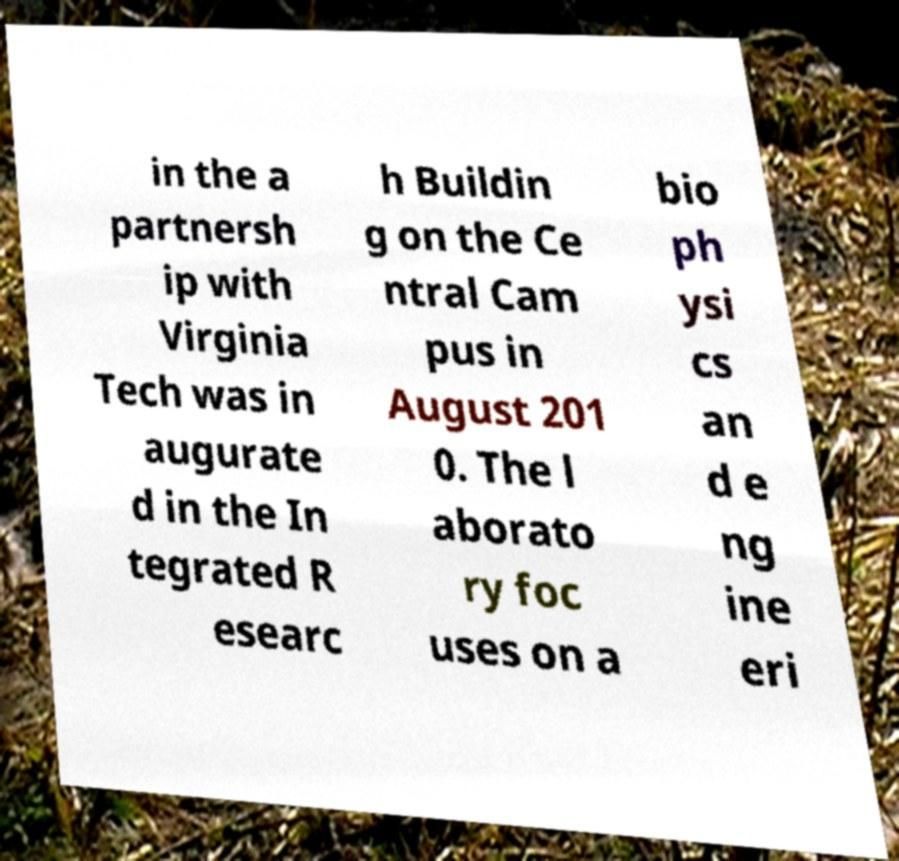I need the written content from this picture converted into text. Can you do that? in the a partnersh ip with Virginia Tech was in augurate d in the In tegrated R esearc h Buildin g on the Ce ntral Cam pus in August 201 0. The l aborato ry foc uses on a bio ph ysi cs an d e ng ine eri 